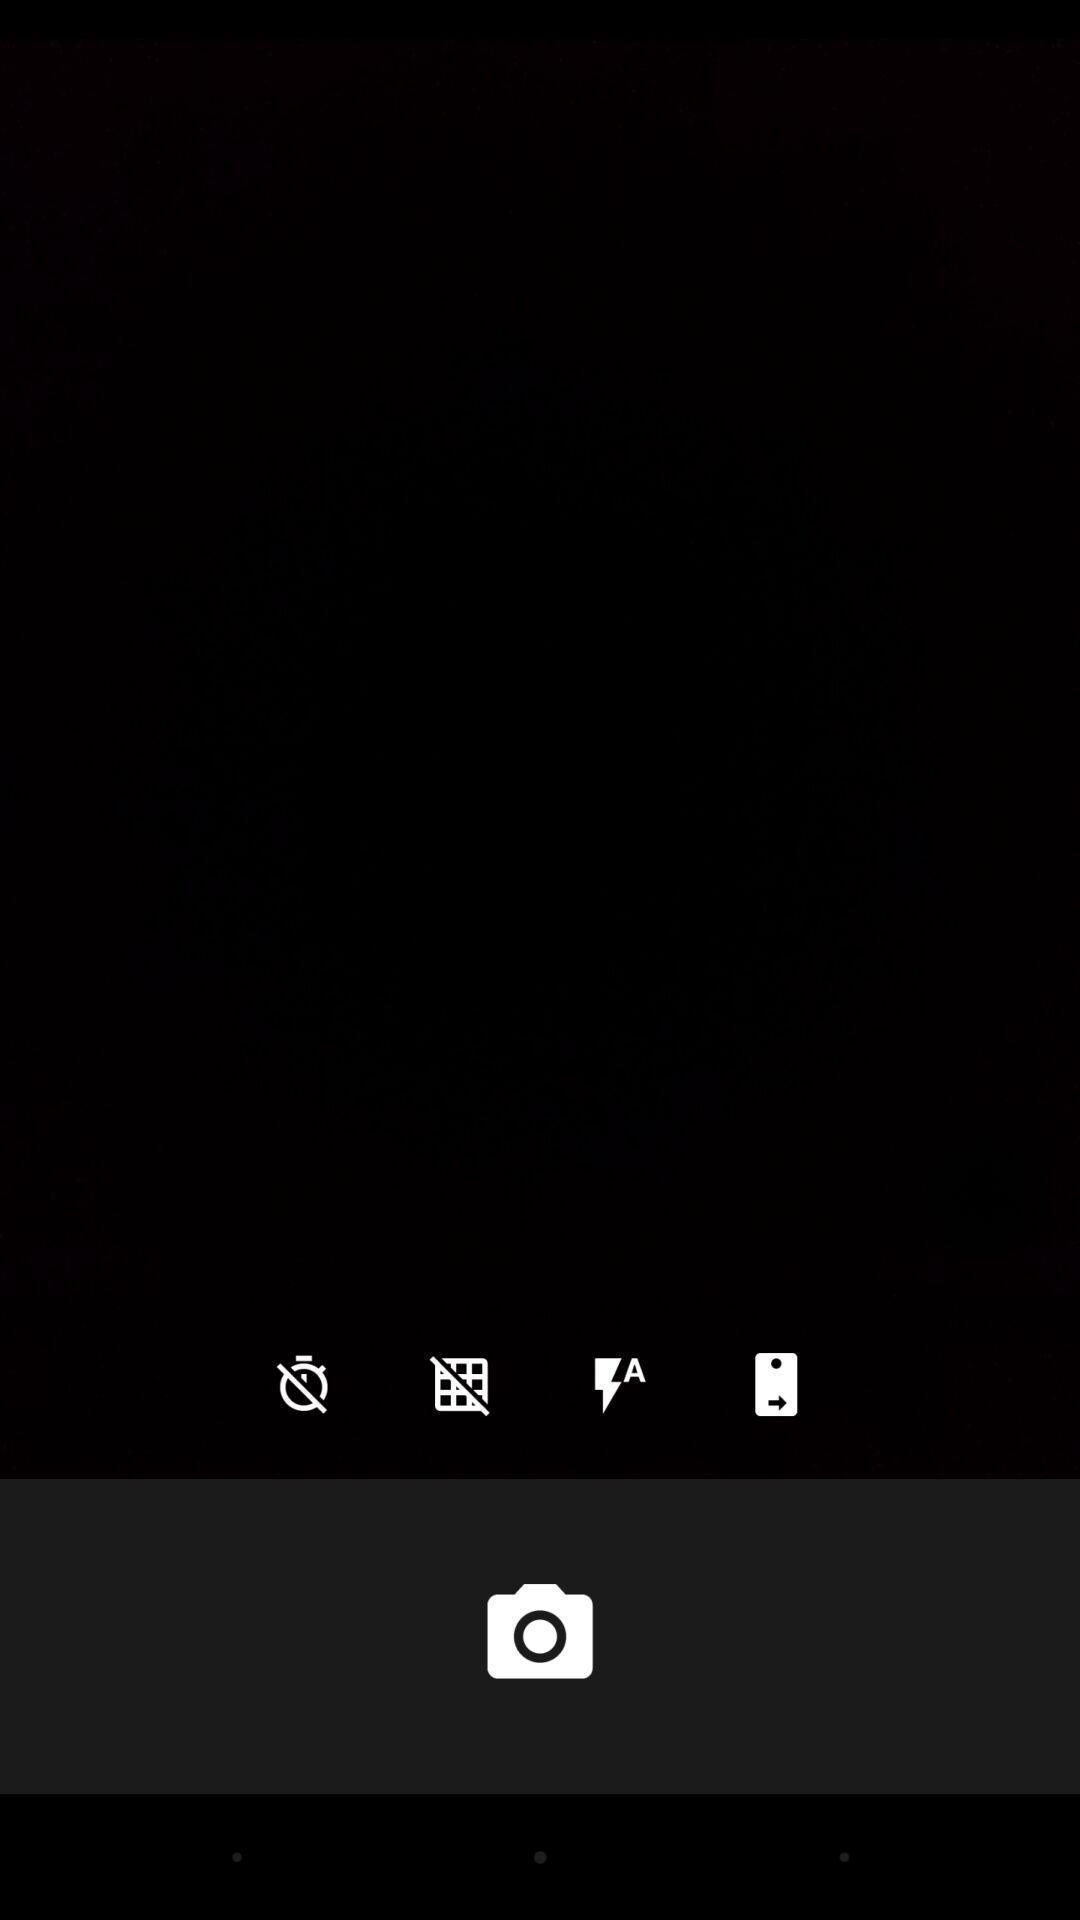What details can you identify in this image? Page showing blank page of a camera app. 